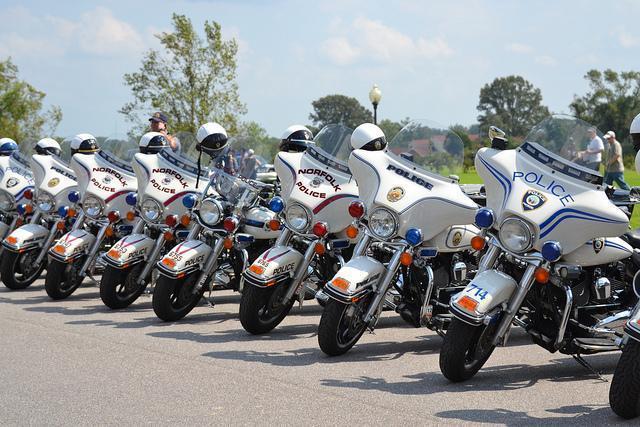What is beneath the number 714?
Pick the correct solution from the four options below to address the question.
Options: Slug, tire, grass, paw. Tire. 